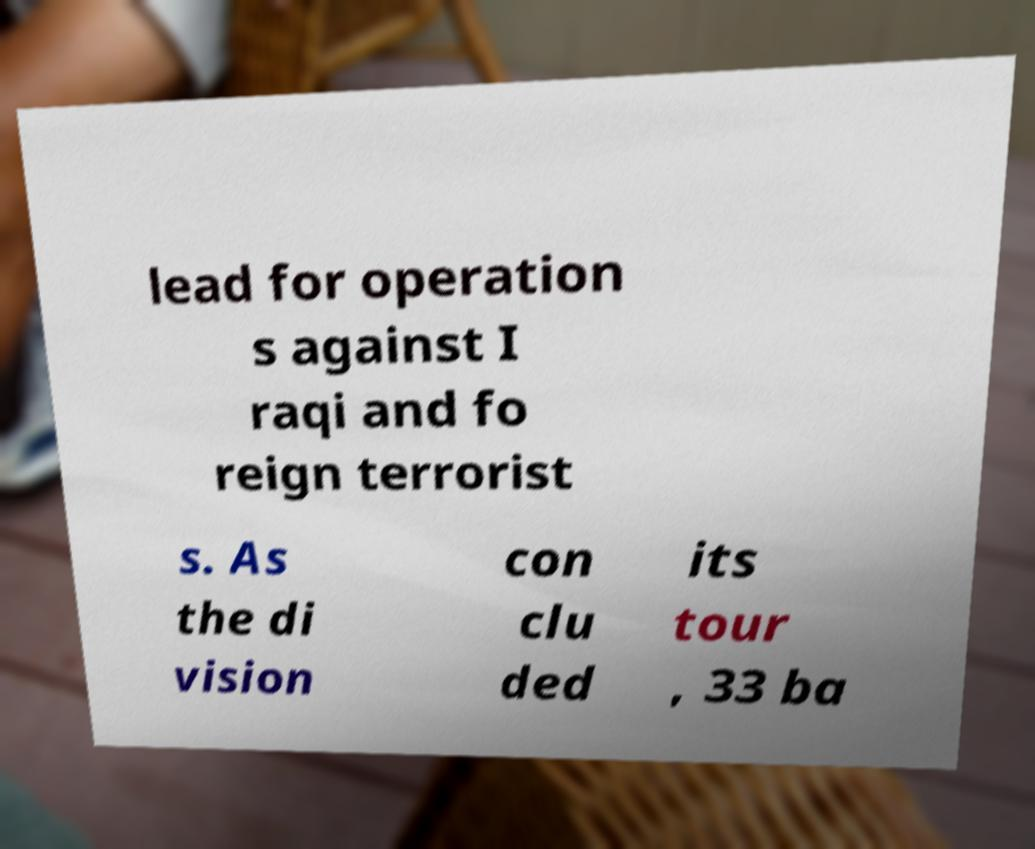Can you accurately transcribe the text from the provided image for me? lead for operation s against I raqi and fo reign terrorist s. As the di vision con clu ded its tour , 33 ba 